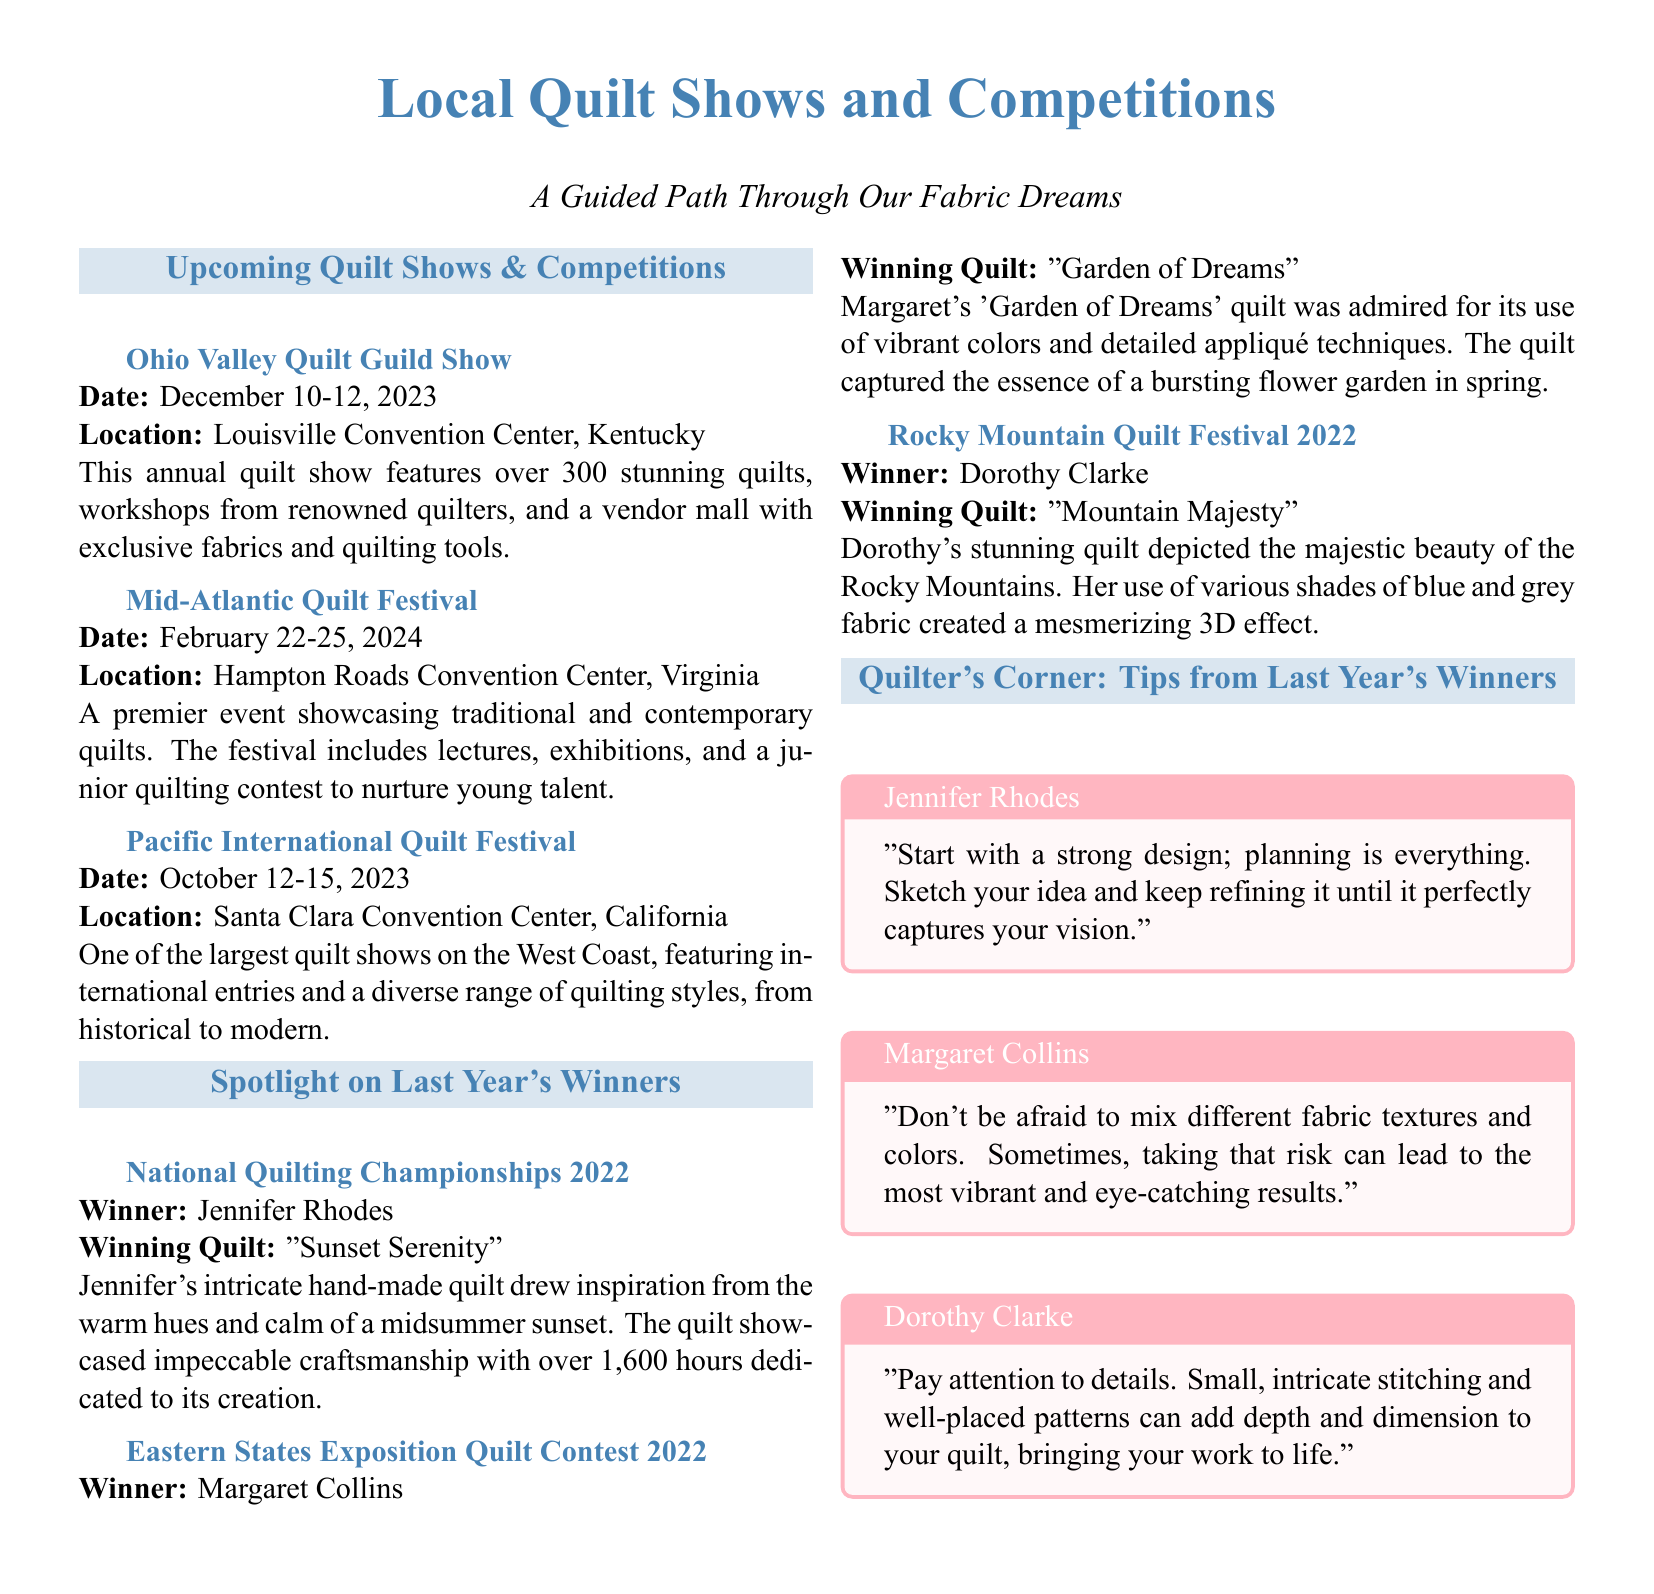What is the date of the Ohio Valley Quilt Guild Show? The date is specifically mentioned in the document as December 10-12, 2023.
Answer: December 10-12, 2023 Where is the Mid-Atlantic Quilt Festival being held? The location is clearly listed in the document as Hampton Roads Convention Center, Virginia.
Answer: Hampton Roads Convention Center, Virginia Who won the National Quilting Championships in 2022? The document states that Jennifer Rhodes is the winner of the National Quilting Championships 2022.
Answer: Jennifer Rhodes What is the title of Margaret Collins' winning quilt? The document includes the title of her quilt, which is "Garden of Dreams."
Answer: Garden of Dreams What is one tip from Jennifer Rhodes? The document includes a quote from Jennifer Rhodes regarding planning and design.
Answer: Start with a strong design; planning is everything How many quilts are featured at the Ohio Valley Quilt Guild Show? The number of quilts is explicitly stated in the document as over 300.
Answer: Over 300 Which event occurs first, the Pacific International Quilt Festival or the Mid-Atlantic Quilt Festival? By comparing the dates mentioned in the document, one can see that the Pacific International Quilt Festival is first in October 2023, while Mid-Atlantic is in February 2024.
Answer: Pacific International Quilt Festival What color is used for the document's section titles? The document mentions the specific color used for section titles as quilt blue.
Answer: quilt blue 